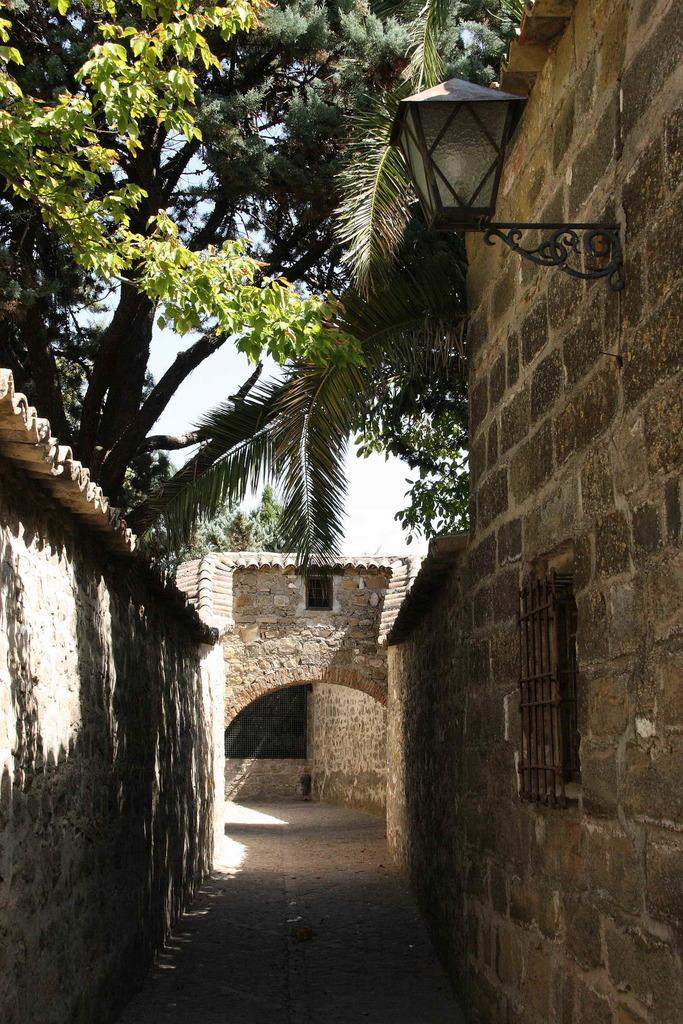What type of structure is present in the image? There is a building in the image. What features can be observed on the building? The building has windows and a roof. What other objects are present in the image? There is a metal grill, a street lamp, and trees in the image. What part of the natural environment is visible in the image? The sky is visible in the image. What type of system is being used by the mother on stage in the image? There is no mother or stage present in the image, so it is not possible to answer that question. 